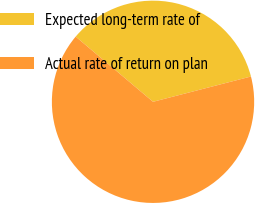Convert chart to OTSL. <chart><loc_0><loc_0><loc_500><loc_500><pie_chart><fcel>Expected long-term rate of<fcel>Actual rate of return on plan<nl><fcel>34.83%<fcel>65.17%<nl></chart> 